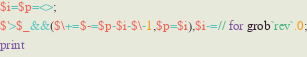<code> <loc_0><loc_0><loc_500><loc_500><_Perl_>$i=$p=<>;
$'>$_&&($\+=$-=$p-$i-$\-1,$p=$i),$i-=// for grob`rev`.0;
print</code> 